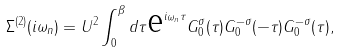<formula> <loc_0><loc_0><loc_500><loc_500>\Sigma ^ { ( 2 ) } ( i \omega _ { n } ) = U ^ { 2 } \int _ { 0 } ^ { \beta } d \tau \text {e} ^ { i \omega _ { n } \tau } G _ { 0 } ^ { \sigma } ( \tau ) G _ { 0 } ^ { - \sigma } ( - \tau ) G _ { 0 } ^ { - \sigma } ( \tau ) ,</formula> 